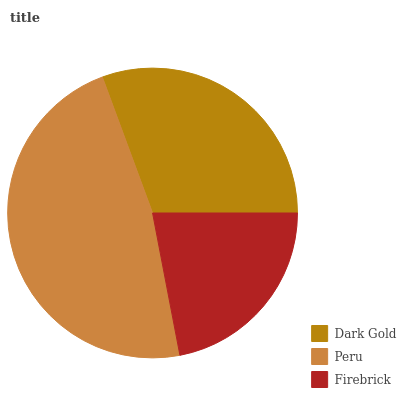Is Firebrick the minimum?
Answer yes or no. Yes. Is Peru the maximum?
Answer yes or no. Yes. Is Peru the minimum?
Answer yes or no. No. Is Firebrick the maximum?
Answer yes or no. No. Is Peru greater than Firebrick?
Answer yes or no. Yes. Is Firebrick less than Peru?
Answer yes or no. Yes. Is Firebrick greater than Peru?
Answer yes or no. No. Is Peru less than Firebrick?
Answer yes or no. No. Is Dark Gold the high median?
Answer yes or no. Yes. Is Dark Gold the low median?
Answer yes or no. Yes. Is Firebrick the high median?
Answer yes or no. No. Is Peru the low median?
Answer yes or no. No. 